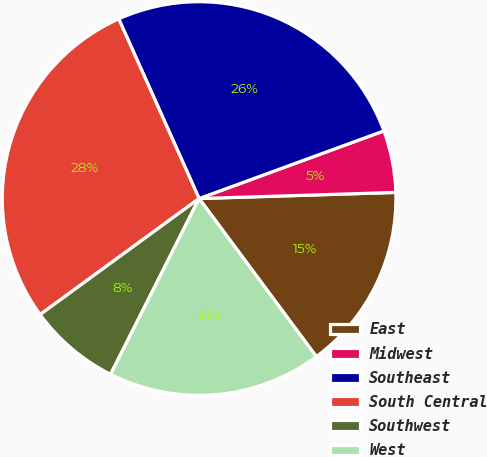Convert chart. <chart><loc_0><loc_0><loc_500><loc_500><pie_chart><fcel>East<fcel>Midwest<fcel>Southeast<fcel>South Central<fcel>Southwest<fcel>West<nl><fcel>15.34%<fcel>5.09%<fcel>26.11%<fcel>28.34%<fcel>7.54%<fcel>17.58%<nl></chart> 